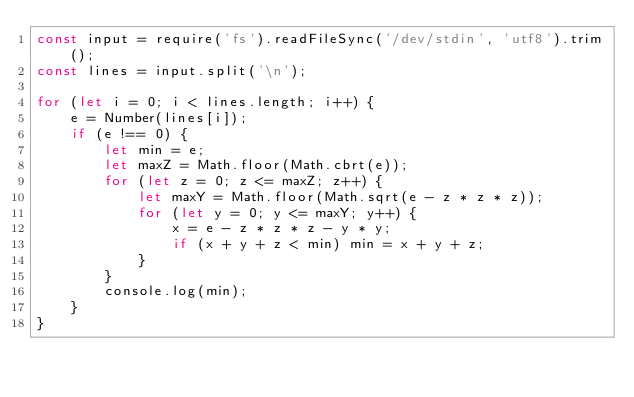<code> <loc_0><loc_0><loc_500><loc_500><_JavaScript_>const input = require('fs').readFileSync('/dev/stdin', 'utf8').trim();
const lines = input.split('\n');

for (let i = 0; i < lines.length; i++) {
	e = Number(lines[i]);
	if (e !== 0) {
		let min = e;
		let maxZ = Math.floor(Math.cbrt(e));
		for (let z = 0; z <= maxZ; z++) {
			let maxY = Math.floor(Math.sqrt(e - z * z * z));
			for (let y = 0; y <= maxY; y++) {
				x = e - z * z * z - y * y;
				if (x + y + z < min) min = x + y + z;
			}
		}
		console.log(min);
    }	
}
</code> 